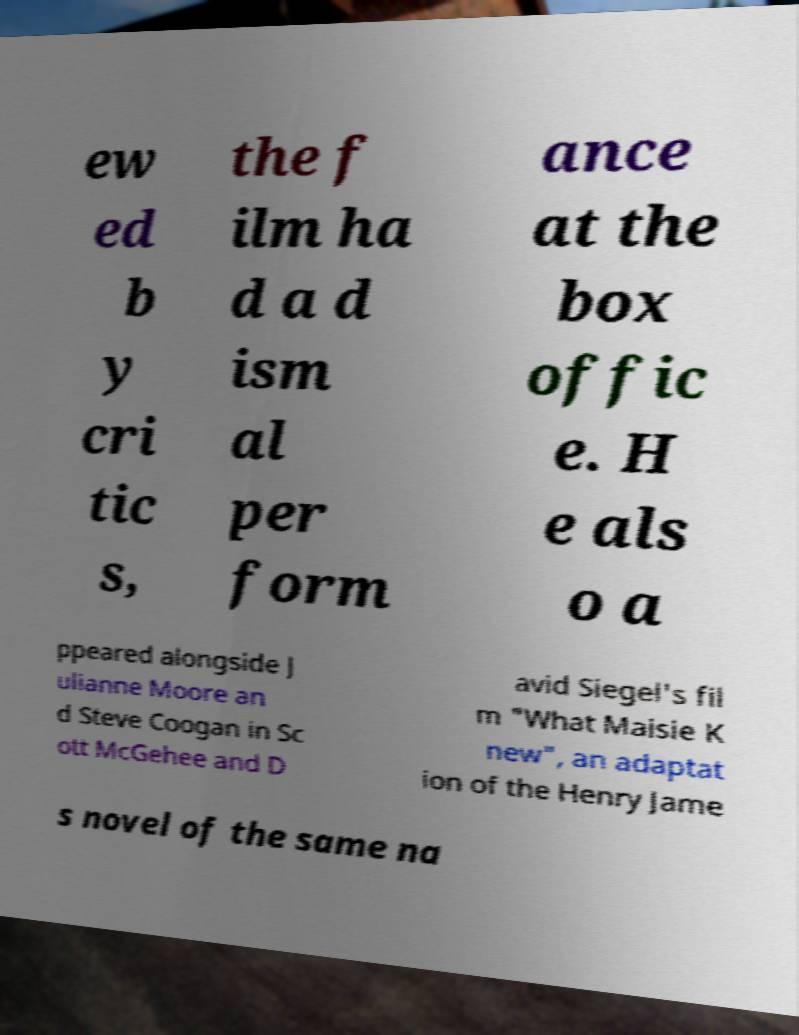Please read and relay the text visible in this image. What does it say? ew ed b y cri tic s, the f ilm ha d a d ism al per form ance at the box offic e. H e als o a ppeared alongside J ulianne Moore an d Steve Coogan in Sc ott McGehee and D avid Siegel's fil m "What Maisie K new", an adaptat ion of the Henry Jame s novel of the same na 